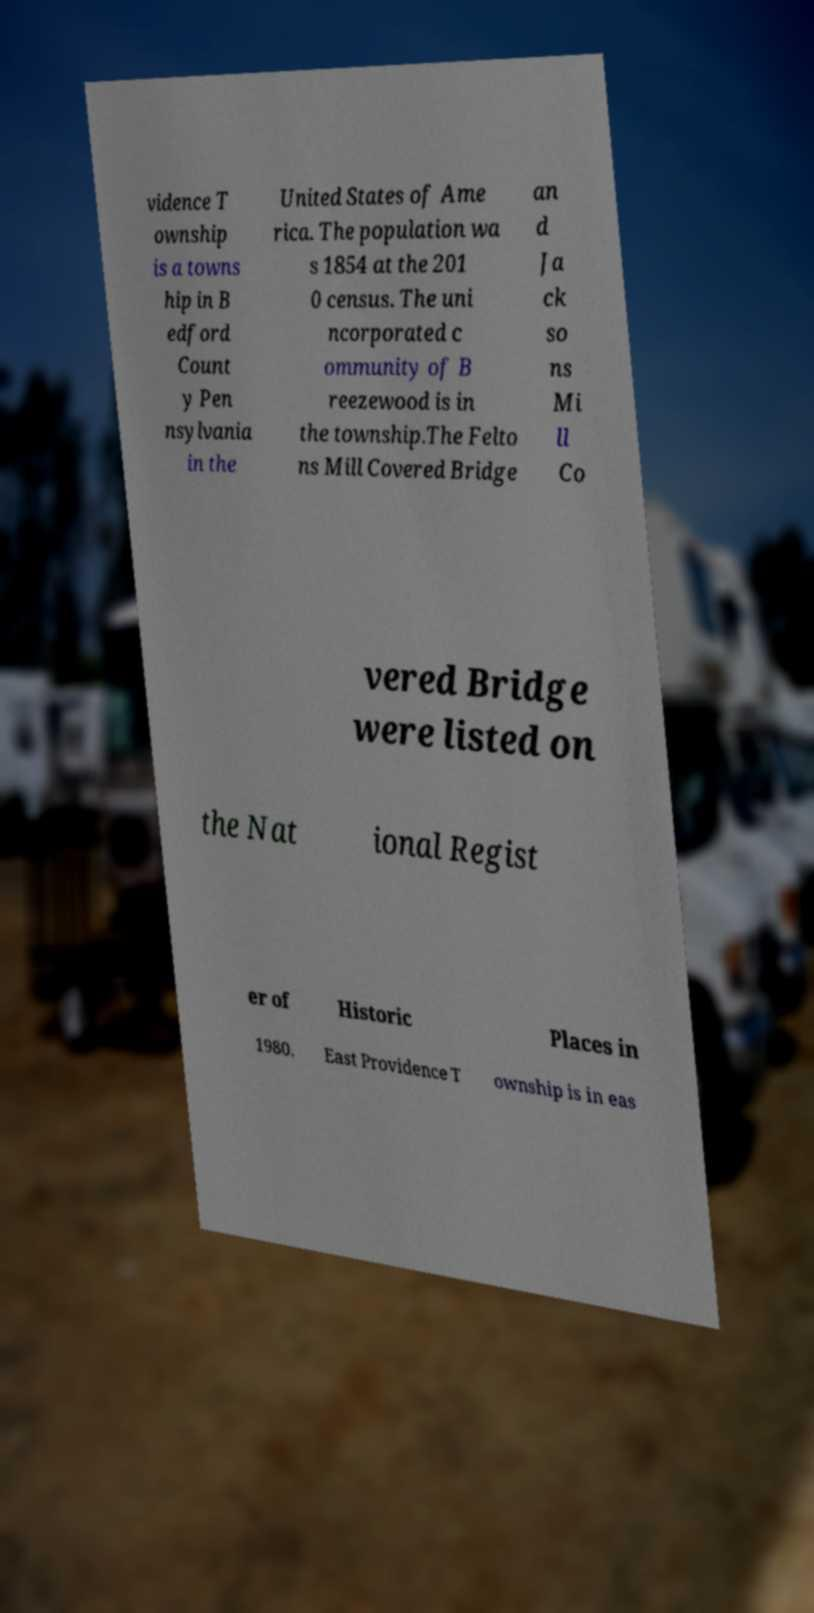What messages or text are displayed in this image? I need them in a readable, typed format. vidence T ownship is a towns hip in B edford Count y Pen nsylvania in the United States of Ame rica. The population wa s 1854 at the 201 0 census. The uni ncorporated c ommunity of B reezewood is in the township.The Felto ns Mill Covered Bridge an d Ja ck so ns Mi ll Co vered Bridge were listed on the Nat ional Regist er of Historic Places in 1980. East Providence T ownship is in eas 